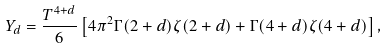Convert formula to latex. <formula><loc_0><loc_0><loc_500><loc_500>Y _ { d } = \frac { T ^ { 4 + d } } { 6 } \left [ 4 \pi ^ { 2 } \Gamma ( 2 + d ) \zeta ( 2 + d ) + \Gamma ( 4 + d ) \zeta ( 4 + d ) \right ] ,</formula> 